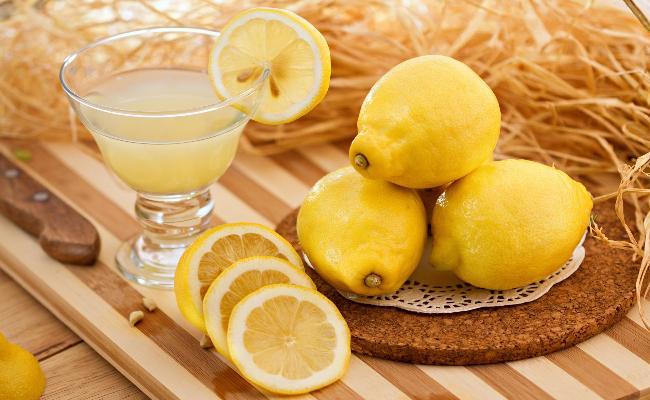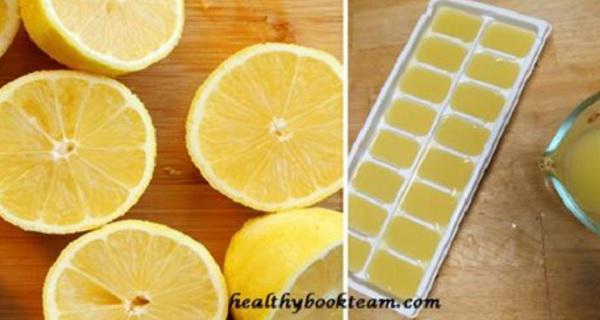The first image is the image on the left, the second image is the image on the right. Considering the images on both sides, is "There are two whole lemons and three lemon halves." valid? Answer yes or no. No. The first image is the image on the left, the second image is the image on the right. Assess this claim about the two images: "The left and right image contains a total of the same full lemons and lemon slices.". Correct or not? Answer yes or no. No. 